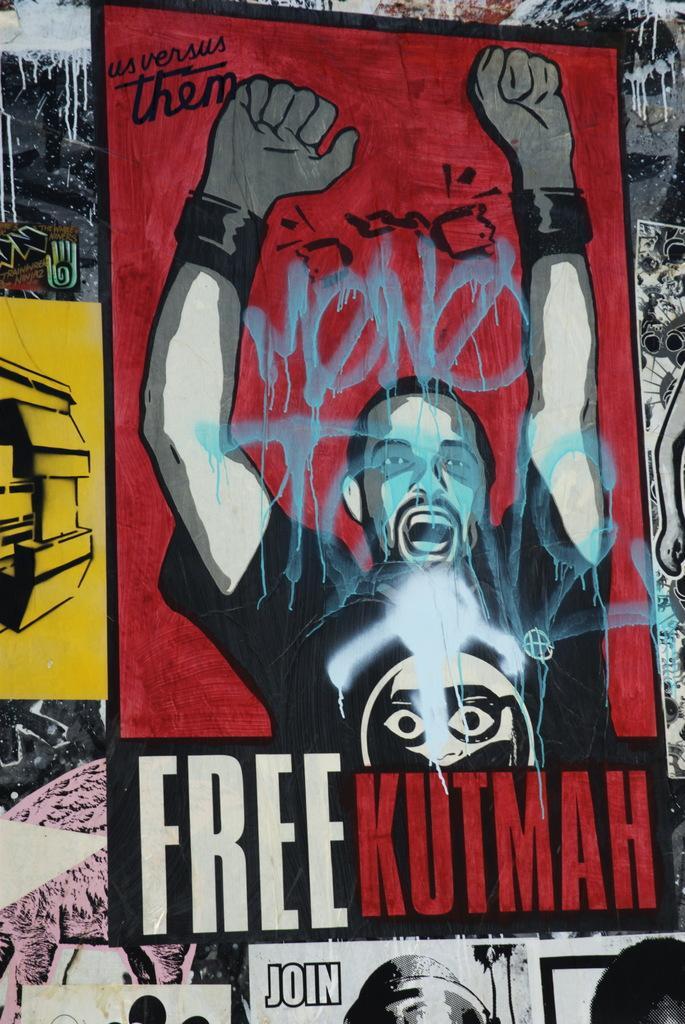Could you give a brief overview of what you see in this image? In this image, we can see few posts. In this poster, we can see a person and some text. 